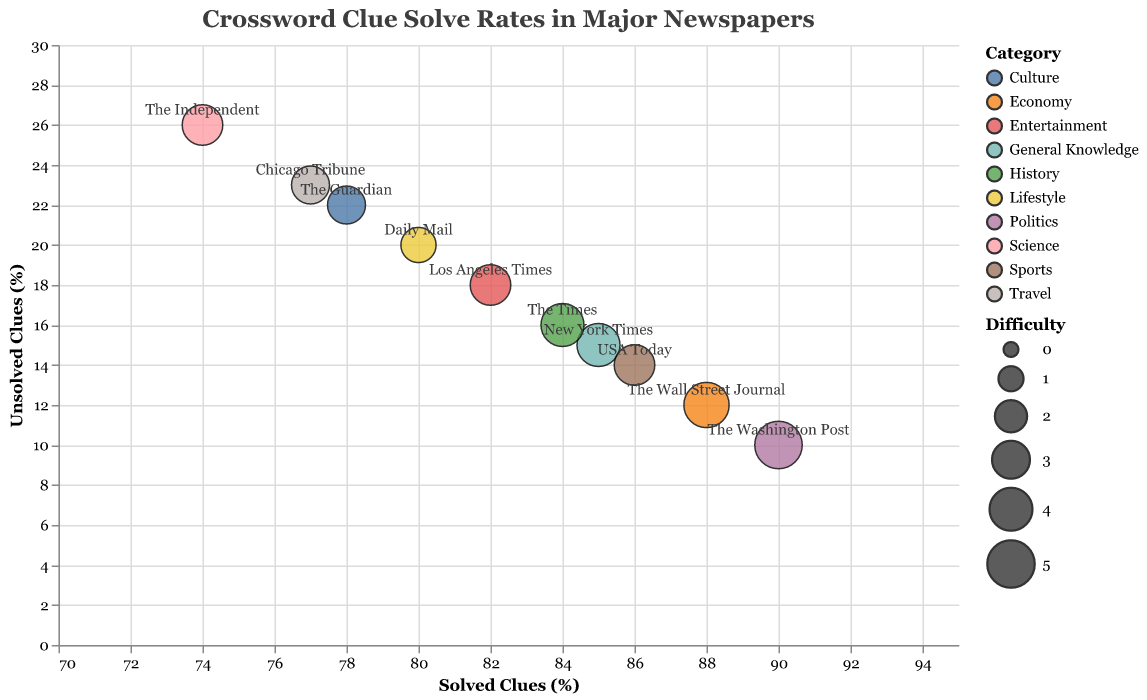What's the title of the figure? The title is usually placed at the top of the figure. It provides a quick summary of what the figure is showing.
Answer: Crossword Clue Solve Rates in Major Newspapers How many categories are shown in the legend? The legend shows different categories by their color. Count the distinct categories within the legend.
Answer: 10 Which newspaper has the highest percentage of solved clues? Look at the x-axis and find the data point that is farthest to the right. Identify the corresponding newspaper from the tooltip.
Answer: The Washington Post Which newspaper has the lowest percentage of unsolved clues? Look at the y-axis and find the data point that is lowest on this axis. Identify the corresponding newspaper from the tooltip.
Answer: The Washington Post What is the difficulty level of the crossword in the Daily Mail? Hover over the bubble for the Daily Mail in the figure and note the difficulty level from the tooltip.
Answer: 2.5 What is the average difficulty level of all newspapers shown? List out the difficulty levels of all newspapers, sum them up, and divide by the number of newspapers. (4 + 3 + 5 + 3.5 + 4.5 + 3.5 + 2.5 + 4 + 3 + 3.5) = 36.5, then 36.5 / 10 = 3.65
Answer: 3.65 Compare the solved and unsolved clues of New York Times to USA Today. Which one has more solved clues? Look at the x-axis values for New York Times and USA Today, which are 85 and 86 respectively. USA Today has one more solved clue percentage point.
Answer: USA Today Which newspaper belongs to the "Science" category, and how well are its clues solved and unsolved? Hover over each bubble until you find "Science" in the tooltip. The newspaper should be "The Independent," and check its solved and unsolved clues.
Answer: The Independent; Solved: 74%, Unsolved: 26% What is the difference in difficulty levels between The Wall Street Journal and The Times? The difficulty level for The Wall Street Journal is 4.5 and for The Times is 4. The difference is 4.5 - 4 = 0.5
Answer: 0.5 Which newspaper falls in the "History" category, and what are their percentages for solved and unsolved clues? Hover over each bubble until you find "History" in the tooltip. The newspaper will be "The Times." Note its solved percentages (84%) and unsolved percentages (16%).
Answer: The Times; Solved: 84%, Unsolved: 16% 